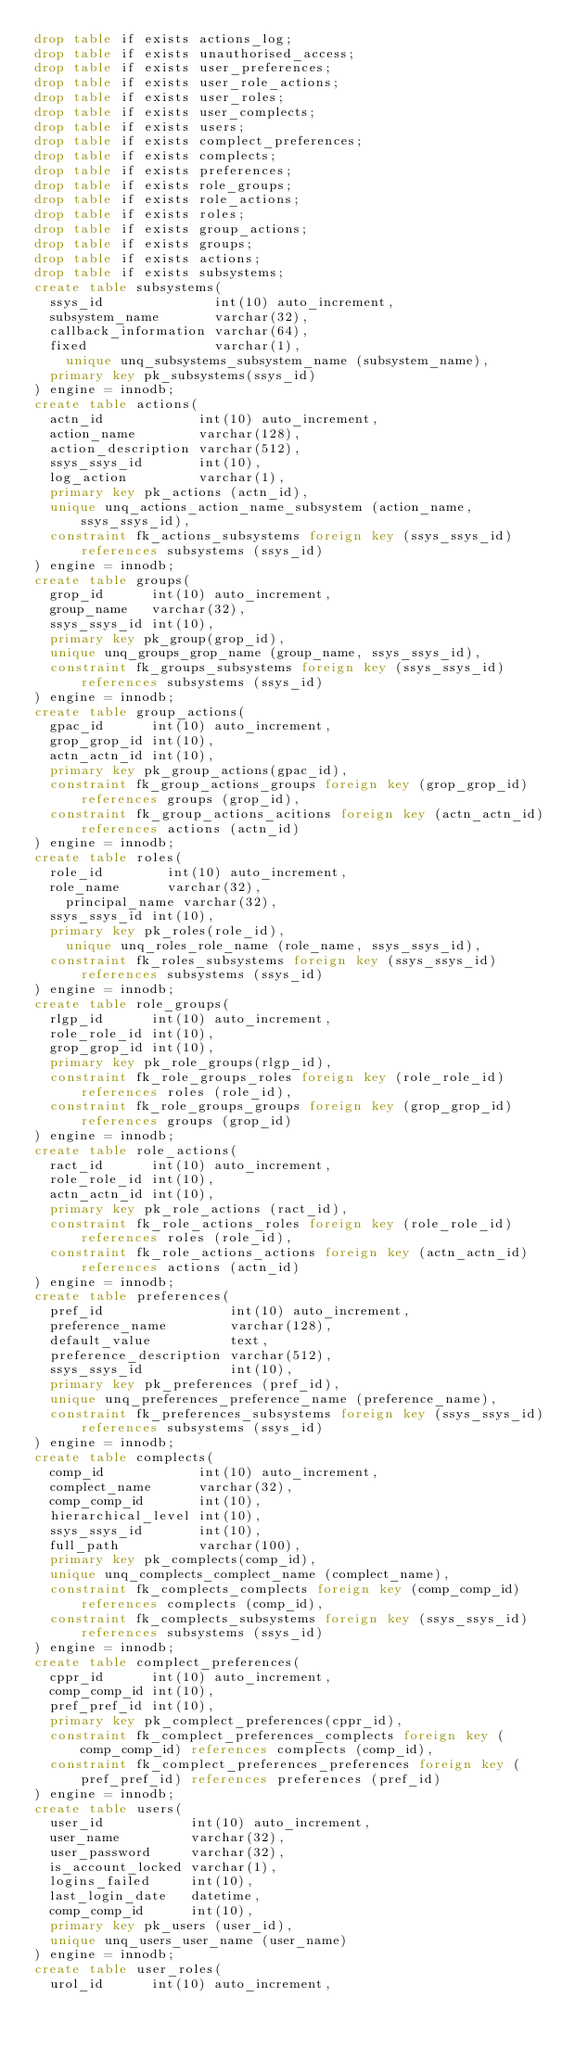<code> <loc_0><loc_0><loc_500><loc_500><_SQL_>drop table if exists actions_log;
drop table if exists unauthorised_access;
drop table if exists user_preferences;
drop table if exists user_role_actions;
drop table if exists user_roles;
drop table if exists user_complects;
drop table if exists users;
drop table if exists complect_preferences;
drop table if exists complects;
drop table if exists preferences;
drop table if exists role_groups;
drop table if exists role_actions;
drop table if exists roles;
drop table if exists group_actions;
drop table if exists groups;
drop table if exists actions;
drop table if exists subsystems;
create table subsystems(
  ssys_id              int(10) auto_increment,
  subsystem_name       varchar(32),
  callback_information varchar(64),
  fixed                varchar(1),
	unique unq_subsystems_subsystem_name (subsystem_name),
  primary key pk_subsystems(ssys_id)
) engine = innodb;
create table actions(
  actn_id            int(10) auto_increment,
  action_name        varchar(128),
  action_description varchar(512),
  ssys_ssys_id       int(10),
  log_action         varchar(1),
  primary key pk_actions (actn_id),
  unique unq_actions_action_name_subsystem (action_name, ssys_ssys_id),
  constraint fk_actions_subsystems foreign key (ssys_ssys_id) references subsystems (ssys_id)
) engine = innodb;
create table groups(
  grop_id      int(10) auto_increment,
  group_name   varchar(32),
  ssys_ssys_id int(10),
  primary key pk_group(grop_id),
  unique unq_groups_grop_name (group_name, ssys_ssys_id),
  constraint fk_groups_subsystems foreign key (ssys_ssys_id) references subsystems (ssys_id)
) engine = innodb;
create table group_actions(
  gpac_id      int(10) auto_increment,
  grop_grop_id int(10),
  actn_actn_id int(10),
  primary key pk_group_actions(gpac_id),
  constraint fk_group_actions_groups foreign key (grop_grop_id) references groups (grop_id),
  constraint fk_group_actions_acitions foreign key (actn_actn_id) references actions (actn_id)
) engine = innodb;
create table roles(
  role_id        int(10) auto_increment,
  role_name      varchar(32),
	principal_name varchar(32),
  ssys_ssys_id int(10),
  primary key pk_roles(role_id),
	unique unq_roles_role_name (role_name, ssys_ssys_id),
  constraint fk_roles_subsystems foreign key (ssys_ssys_id) references subsystems (ssys_id)
) engine = innodb;
create table role_groups(
  rlgp_id      int(10) auto_increment,
  role_role_id int(10),
  grop_grop_id int(10),
  primary key pk_role_groups(rlgp_id),
  constraint fk_role_groups_roles foreign key (role_role_id) references roles (role_id),
  constraint fk_role_groups_groups foreign key (grop_grop_id) references groups (grop_id)
) engine = innodb;
create table role_actions(
  ract_id      int(10) auto_increment,
  role_role_id int(10),
  actn_actn_id int(10),
  primary key pk_role_actions (ract_id),
  constraint fk_role_actions_roles foreign key (role_role_id) references roles (role_id),
  constraint fk_role_actions_actions foreign key (actn_actn_id) references actions (actn_id)
) engine = innodb;
create table preferences(
  pref_id                int(10) auto_increment,
  preference_name        varchar(128),
  default_value          text,
  preference_description varchar(512),
  ssys_ssys_id           int(10),
  primary key pk_preferences (pref_id),
  unique unq_preferences_preference_name (preference_name),
  constraint fk_preferences_subsystems foreign key (ssys_ssys_id) references subsystems (ssys_id)
) engine = innodb;
create table complects(
  comp_id            int(10) auto_increment,
  complect_name      varchar(32),
  comp_comp_id       int(10),
  hierarchical_level int(10),
  ssys_ssys_id       int(10),
  full_path          varchar(100),
  primary key pk_complects(comp_id),
  unique unq_complects_complect_name (complect_name),
  constraint fk_complects_complects foreign key (comp_comp_id) references complects (comp_id),
  constraint fk_complects_subsystems foreign key (ssys_ssys_id) references subsystems (ssys_id)
) engine = innodb;
create table complect_preferences(
  cppr_id      int(10) auto_increment,
  comp_comp_id int(10),
  pref_pref_id int(10),
  primary key pk_complect_preferences(cppr_id),
  constraint fk_complect_preferences_complects foreign key (comp_comp_id) references complects (comp_id),
  constraint fk_complect_preferences_preferences foreign key (pref_pref_id) references preferences (pref_id)
) engine = innodb;
create table users(
  user_id           int(10) auto_increment,
  user_name         varchar(32),
  user_password     varchar(32),
  is_account_locked varchar(1),
  logins_failed     int(10),
  last_login_date   datetime,
  comp_comp_id      int(10),
  primary key pk_users (user_id),
  unique unq_users_user_name (user_name)
) engine = innodb;
create table user_roles(
  urol_id      int(10) auto_increment,</code> 